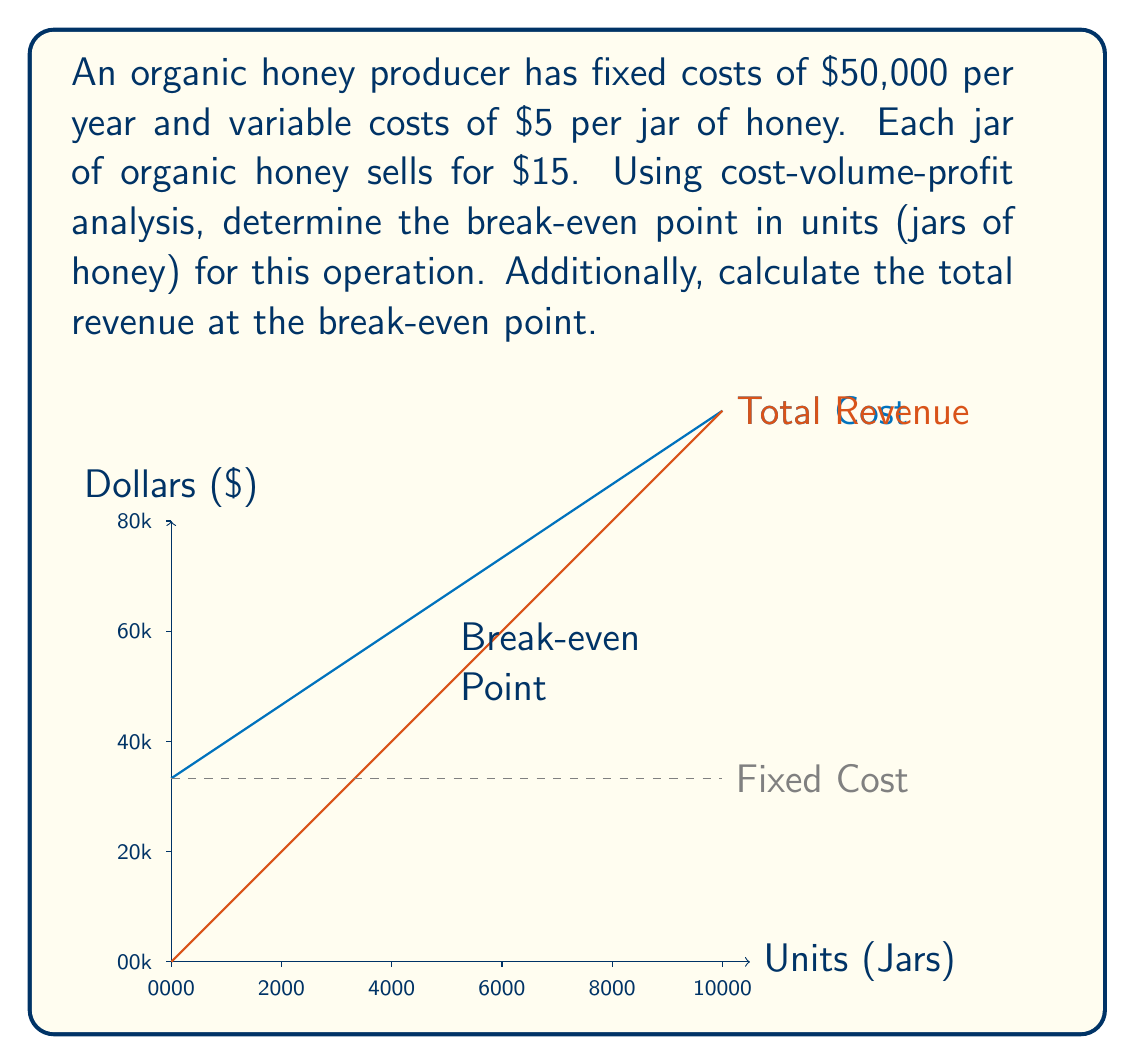Provide a solution to this math problem. To solve this problem, we'll use the cost-volume-profit (CVP) analysis approach:

1) First, let's define our variables:
   $FC$ = Fixed Costs = $50,000
   $VC$ = Variable Cost per unit = $5
   $P$ = Price per unit = $15
   $X$ = Break-even quantity in units

2) The break-even point occurs when Total Revenue equals Total Cost:
   $TR = TC$
   $PX = FC + VCX$

3) Substitute the known values:
   $15X = 50,000 + 5X$

4) Solve for $X$:
   $15X - 5X = 50,000$
   $10X = 50,000$
   $X = 5,000$ jars

5) To calculate the total revenue at the break-even point:
   $TR = PX = 15 * 5,000 = $75,000$

Therefore, the organic honey producer needs to sell 5,000 jars of honey to break even, and at this point, the total revenue will be $75,000.
Answer: Break-even point: 5,000 jars; Total revenue at break-even: $75,000 